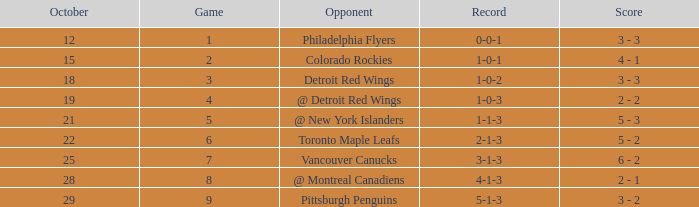Name the most october for game less than 1 None. Could you parse the entire table? {'header': ['October', 'Game', 'Opponent', 'Record', 'Score'], 'rows': [['12', '1', 'Philadelphia Flyers', '0-0-1', '3 - 3'], ['15', '2', 'Colorado Rockies', '1-0-1', '4 - 1'], ['18', '3', 'Detroit Red Wings', '1-0-2', '3 - 3'], ['19', '4', '@ Detroit Red Wings', '1-0-3', '2 - 2'], ['21', '5', '@ New York Islanders', '1-1-3', '5 - 3'], ['22', '6', 'Toronto Maple Leafs', '2-1-3', '5 - 2'], ['25', '7', 'Vancouver Canucks', '3-1-3', '6 - 2'], ['28', '8', '@ Montreal Canadiens', '4-1-3', '2 - 1'], ['29', '9', 'Pittsburgh Penguins', '5-1-3', '3 - 2']]} 